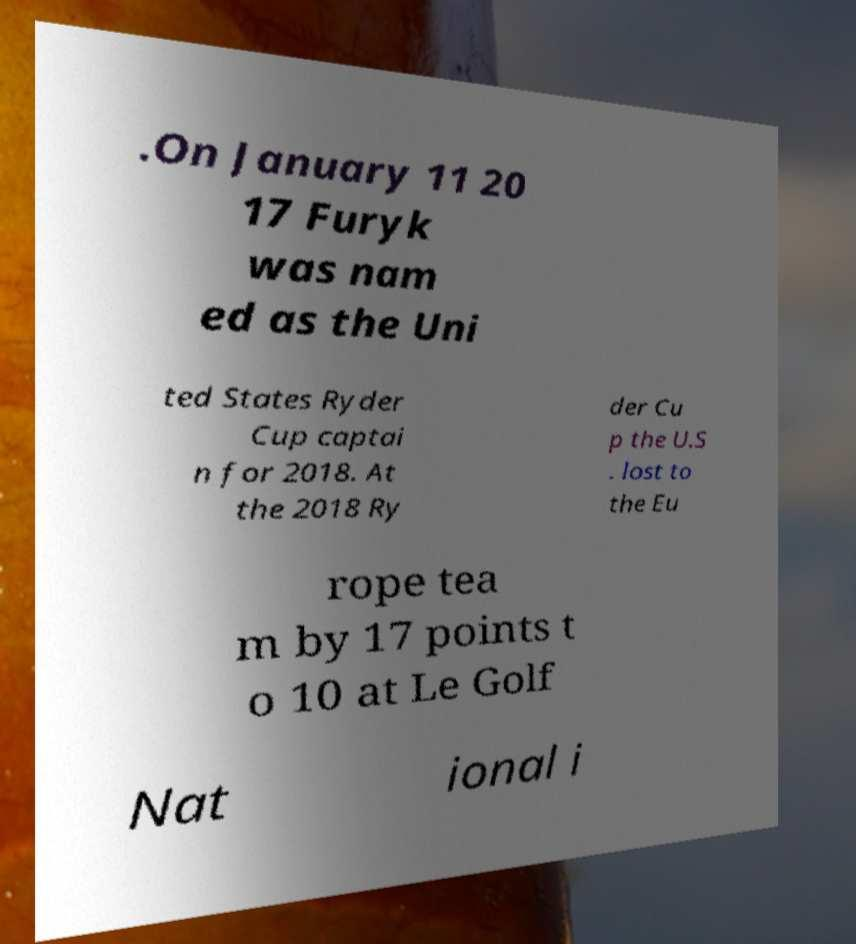Could you extract and type out the text from this image? .On January 11 20 17 Furyk was nam ed as the Uni ted States Ryder Cup captai n for 2018. At the 2018 Ry der Cu p the U.S . lost to the Eu rope tea m by 17 points t o 10 at Le Golf Nat ional i 